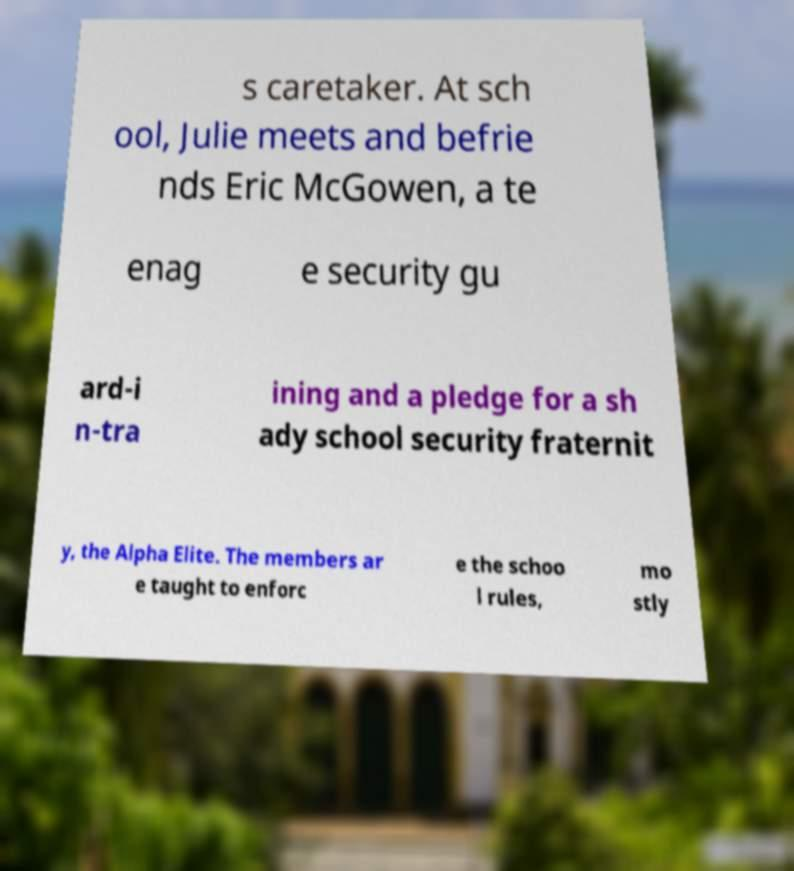Please read and relay the text visible in this image. What does it say? s caretaker. At sch ool, Julie meets and befrie nds Eric McGowen, a te enag e security gu ard-i n-tra ining and a pledge for a sh ady school security fraternit y, the Alpha Elite. The members ar e taught to enforc e the schoo l rules, mo stly 